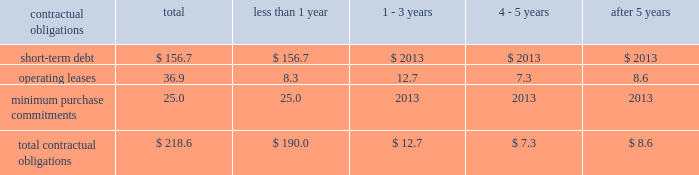Z i m m e r h o l d i n g s , i n c .
A n d s u b s i d i a r i e s 2 0 0 2 f o r m 1 0 - k contractual obligations the company has entered into contracts with various third parties in the normal course of business which will require future payments .
The table illustrates the company 2019s contractual obligations : than 1 1 - 3 4 - 5 after 5 contractual obligations total year years years years .
Critical accounting policies equipment based on historical patterns of use and physical and technological characteristics of assets , as the financial results of the company are affected by the appropriate .
In accordance with statement of financial selection and application of accounting policies and methods .
Accounting standards ( 2018 2018sfas 2019 2019 ) no .
144 , 2018 2018accounting for significant accounting policies which , in some cases , require the impairment or disposal of long-lived assets , 2019 2019 the management 2019s judgment are discussed below .
Company reviews property , plant and equipment for revenue recognition 2013 a significant portion of the com- impairment whenever events or changes in circumstances pany 2019s revenue is recognized for field based product upon indicate that the carrying value of an asset may not be notification that the product has been implanted or used .
Recoverable .
An impairment loss would be recognized for all other transactions , the company recognizes when estimated future cash flows relating to the asset revenue when title is passed to customers , generally are less than its carrying amount .
Upon shipment .
Estimated returns and allowances are derivative financial instruments 2013 critical aspects of recorded as a reduction of sales when the revenue is the company 2019s accounting policy for derivative financial recognized .
Instruments include conditions which require that critical inventories 2013 the company must determine as of each terms of a hedging instrument are essentially the same as balance sheet date how much , if any , of its inventory may a hedged forecasted transaction .
Another important ele- ultimately prove to be unsaleable or unsaleable at its ment of the policy requires that formal documentation be carrying cost .
Reserves are established to effectively maintained as required by the sfas no .
133 , 2018 2018accounting adjust any such inventory to net realizable value .
To for derivative instruments and hedging activities . 2019 2019 fail- determine the appropriate level of reserves , the company ure to comply with these conditions would result in a evaluates current stock levels in relation to historical and requirement to recognize changes in market value of expected patterns of demand for all of its products .
A hedge instruments in earnings as they occur .
Manage- series of algorithms is applied to the data to assist ment routinely monitors significant estimates , assump- management in its evaluation .
Management evaluates the tions and judgments associated with derivative need for changes to valuation reserves based on market instruments , and compliance with formal documentation conditions , competitive offerings and other factors on a requirements .
Regular basis .
Further information about inventory stock compensation 2013 the company applies the provi- reserves is provided in notes to the consolidated financial sions of apb opinion no .
25 , 2018 2018accounting for stock statements .
Issued to employees , 2019 2019 in accounting for stock-based instruments 2013 the company , as is customary in the compensation ; therefore , no compensation expense has industry , consigns surgical instruments for use in been recognized for its fixed stock option plans as orthopaedic procedures with the company 2019s products .
Options are granted at fair market value .
Sfas no .
123 , the company 2019s accounting policy requires that the full 2018 2018accounting for stock-based compensation 2019 2019 provides an cost of instruments be recognized as an expense in the alternative method of accounting for stock options based year in which the instruments are placed in service .
An on an option pricing model , such as black-scholes .
The alternative to this method is to depreciate the cost of company has adopted the disclosure requirements of instruments over their useful lives .
The company may sfas no .
123 and sfas no .
148 , 2018 2018accounting for stock- from time to time consider a change in accounting for based compensation-transition and disclosure . 2019 2019 informa- instruments to better align its accounting policy with tion regarding compensation expense under the alterna- certain company competitors .
Tive method is provided in notes to the consolidated financial statements .
Property , plant and equipment 2013 the company deter- mines estimated useful lives of property , plant and .
What percent of total contractual obligations is comprised of short-term debt? 
Computations: (156.7 / 218.6)
Answer: 0.71683. 